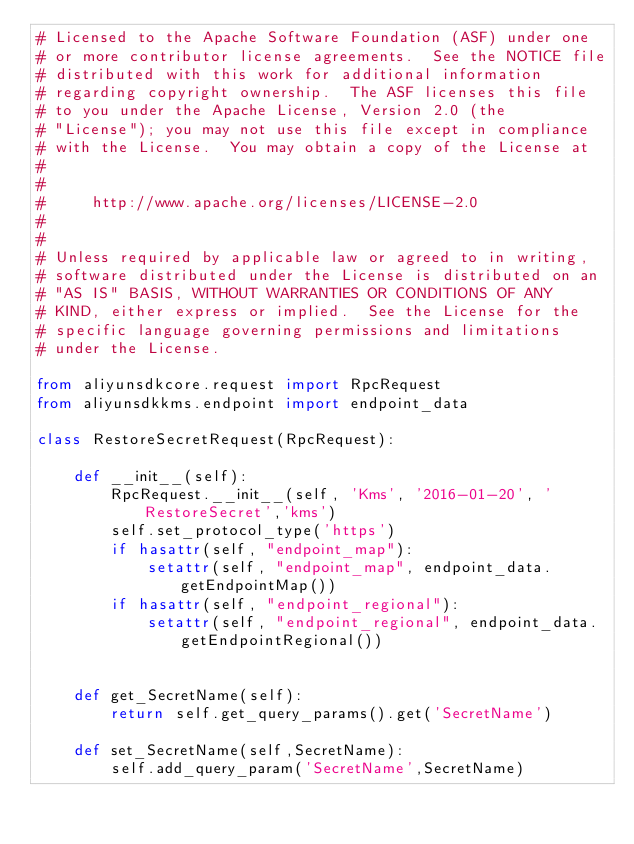<code> <loc_0><loc_0><loc_500><loc_500><_Python_># Licensed to the Apache Software Foundation (ASF) under one
# or more contributor license agreements.  See the NOTICE file
# distributed with this work for additional information
# regarding copyright ownership.  The ASF licenses this file
# to you under the Apache License, Version 2.0 (the
# "License"); you may not use this file except in compliance
# with the License.  You may obtain a copy of the License at
#
#
#     http://www.apache.org/licenses/LICENSE-2.0
#
#
# Unless required by applicable law or agreed to in writing,
# software distributed under the License is distributed on an
# "AS IS" BASIS, WITHOUT WARRANTIES OR CONDITIONS OF ANY
# KIND, either express or implied.  See the License for the
# specific language governing permissions and limitations
# under the License.

from aliyunsdkcore.request import RpcRequest
from aliyunsdkkms.endpoint import endpoint_data

class RestoreSecretRequest(RpcRequest):

	def __init__(self):
		RpcRequest.__init__(self, 'Kms', '2016-01-20', 'RestoreSecret','kms')
		self.set_protocol_type('https')
		if hasattr(self, "endpoint_map"):
			setattr(self, "endpoint_map", endpoint_data.getEndpointMap())
		if hasattr(self, "endpoint_regional"):
			setattr(self, "endpoint_regional", endpoint_data.getEndpointRegional())


	def get_SecretName(self):
		return self.get_query_params().get('SecretName')

	def set_SecretName(self,SecretName):
		self.add_query_param('SecretName',SecretName)</code> 